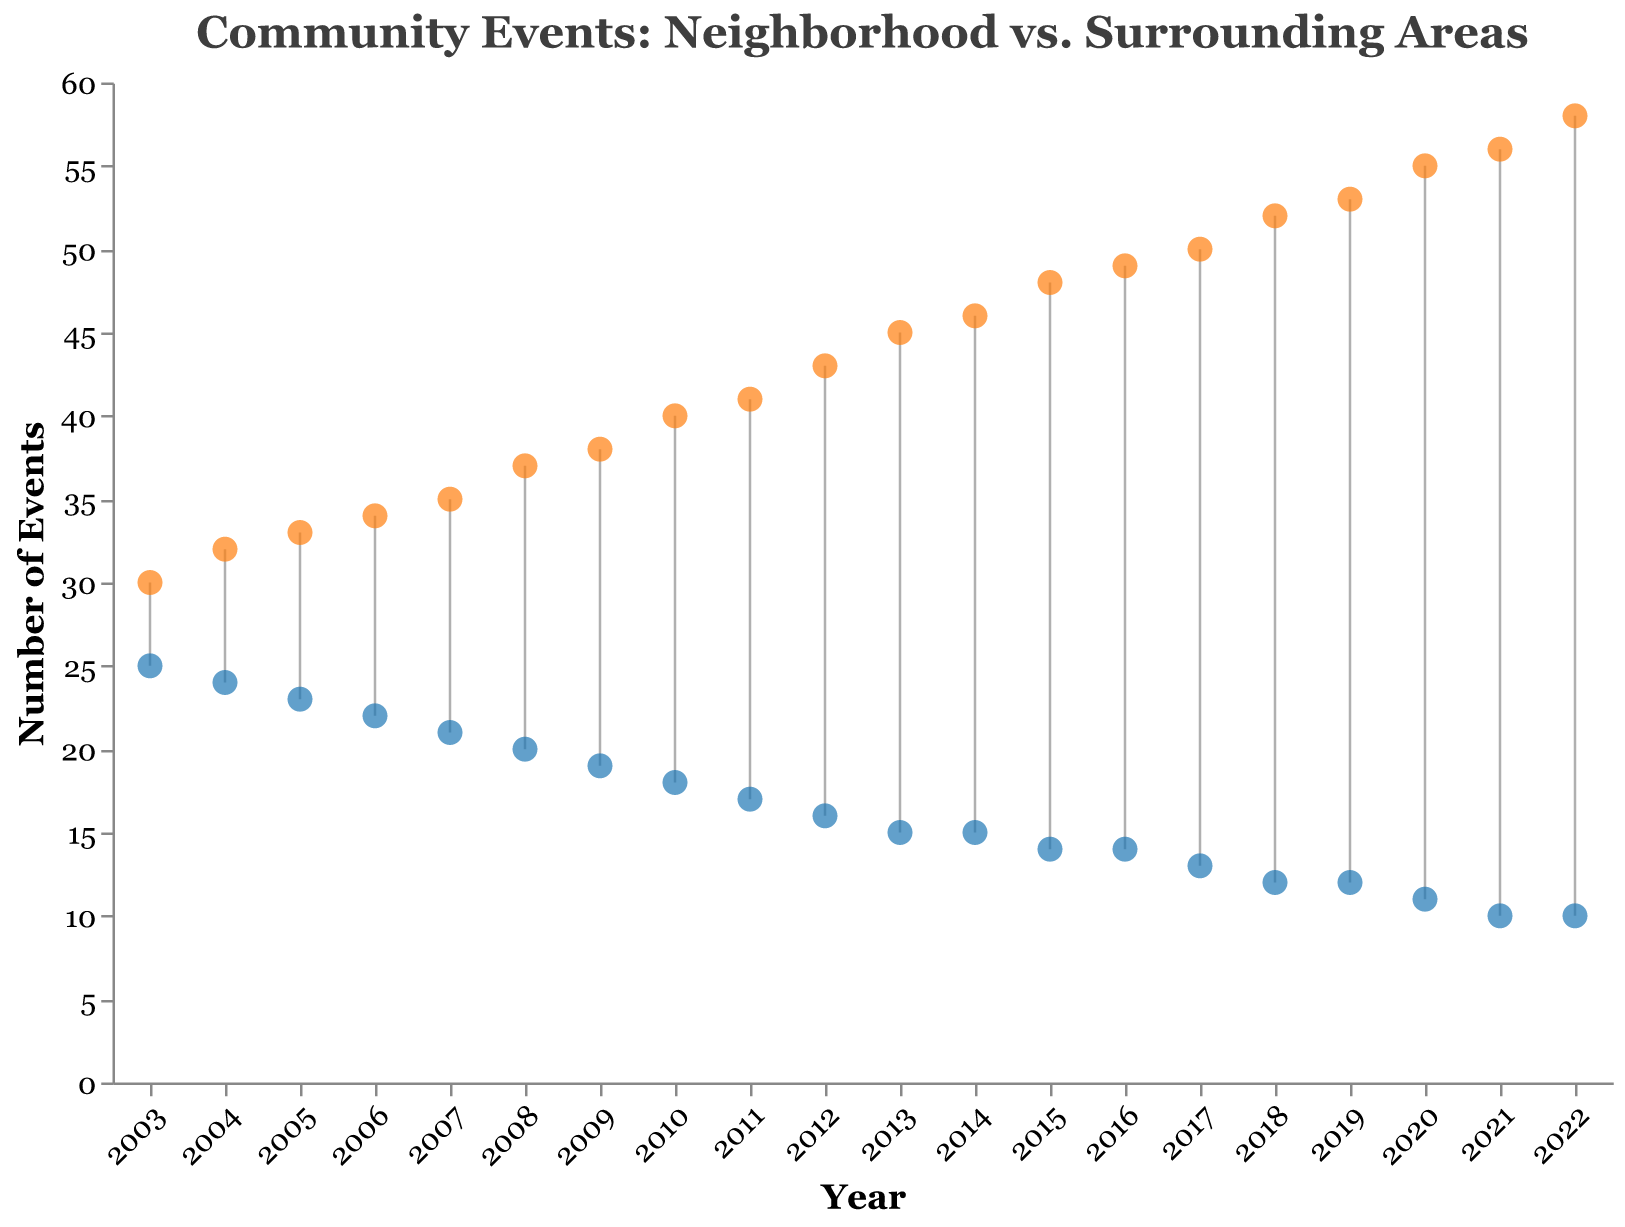What is the title of the figure? The title of the figure is displayed at the top and provides an overview of the content. It states the main subject being depicted in the visual.
Answer: Community Events: Neighborhood vs. Surrounding Areas What year has the highest number of community events in the neighborhood? By looking at the y-axis values for the blue points, we can see that the year with the highest number is towards the left. The highest value in the Neighborhood_Events column is 25.
Answer: 2003 How many community events were held in 2016 in the surrounding areas? Locate the year 2016 on the x-axis and then observe the corresponding orange point on the y-axis. The value for Surrounding_Areas_Events is 49.
Answer: 49 What is the color used to represent neighborhood community events? The visual representation of the Neighborhood_Events is shown in blue circles. This is consistent throughout the plot for the neighborhood data points.
Answer: Blue What trend do you see in the number of community events in the neighborhood over the years from 2003 to 2022? Observing the blue points and their positions on the y-axis from the left to the right, there is a clear declining trend in the number of community events in the neighborhood over the years.
Answer: Decreasing By how much did the number of community events in the surrounding areas increase from 2003 to 2022? To find the increase, subtract the number of events in 2003 from the number in 2022. In 2003, the number of Surrounding_Areas_Events is 30, and in 2022 it is 58. The increase is 58 - 30.
Answer: 28 What is the difference in the number of community events between the neighborhood and surrounding areas in 2021? Locate 2021 on the x-axis. The values for 2021 are 10 for the neighborhood and 56 for the surrounding areas. The difference is 56 - 10.
Answer: 46 In what year did the neighborhood have the same number of community events as in the following year? By examining the blue points, find a year where the same number appears consecutively. The neighborhood had 14 events in both 2015 and 2016.
Answer: 2015 Which year showed the sharpest decline in community events in the neighborhood compared to the previous year? Observe the year-to-year differences among the blue points. The sharpest decline should show the largest negative difference. From 2004 to 2005, it dropped by 1, but from 2012 to 2013, it dropped by 1 as well. Checking for consecutive years, the steepest decline seems to be consistent but notable around these intervals.
Answer: Consistent single-drop years 